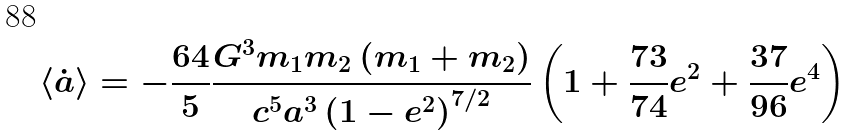<formula> <loc_0><loc_0><loc_500><loc_500>\langle \dot { a } \rangle = - \frac { 6 4 } { 5 } \frac { G ^ { 3 } m _ { 1 } m _ { 2 } \left ( m _ { 1 } + m _ { 2 } \right ) } { c ^ { 5 } a ^ { 3 } \left ( 1 - e ^ { 2 } \right ) ^ { 7 / 2 } } \left ( 1 + \frac { 7 3 } { 7 4 } e ^ { 2 } + \frac { 3 7 } { 9 6 } e ^ { 4 } \right ) \</formula> 